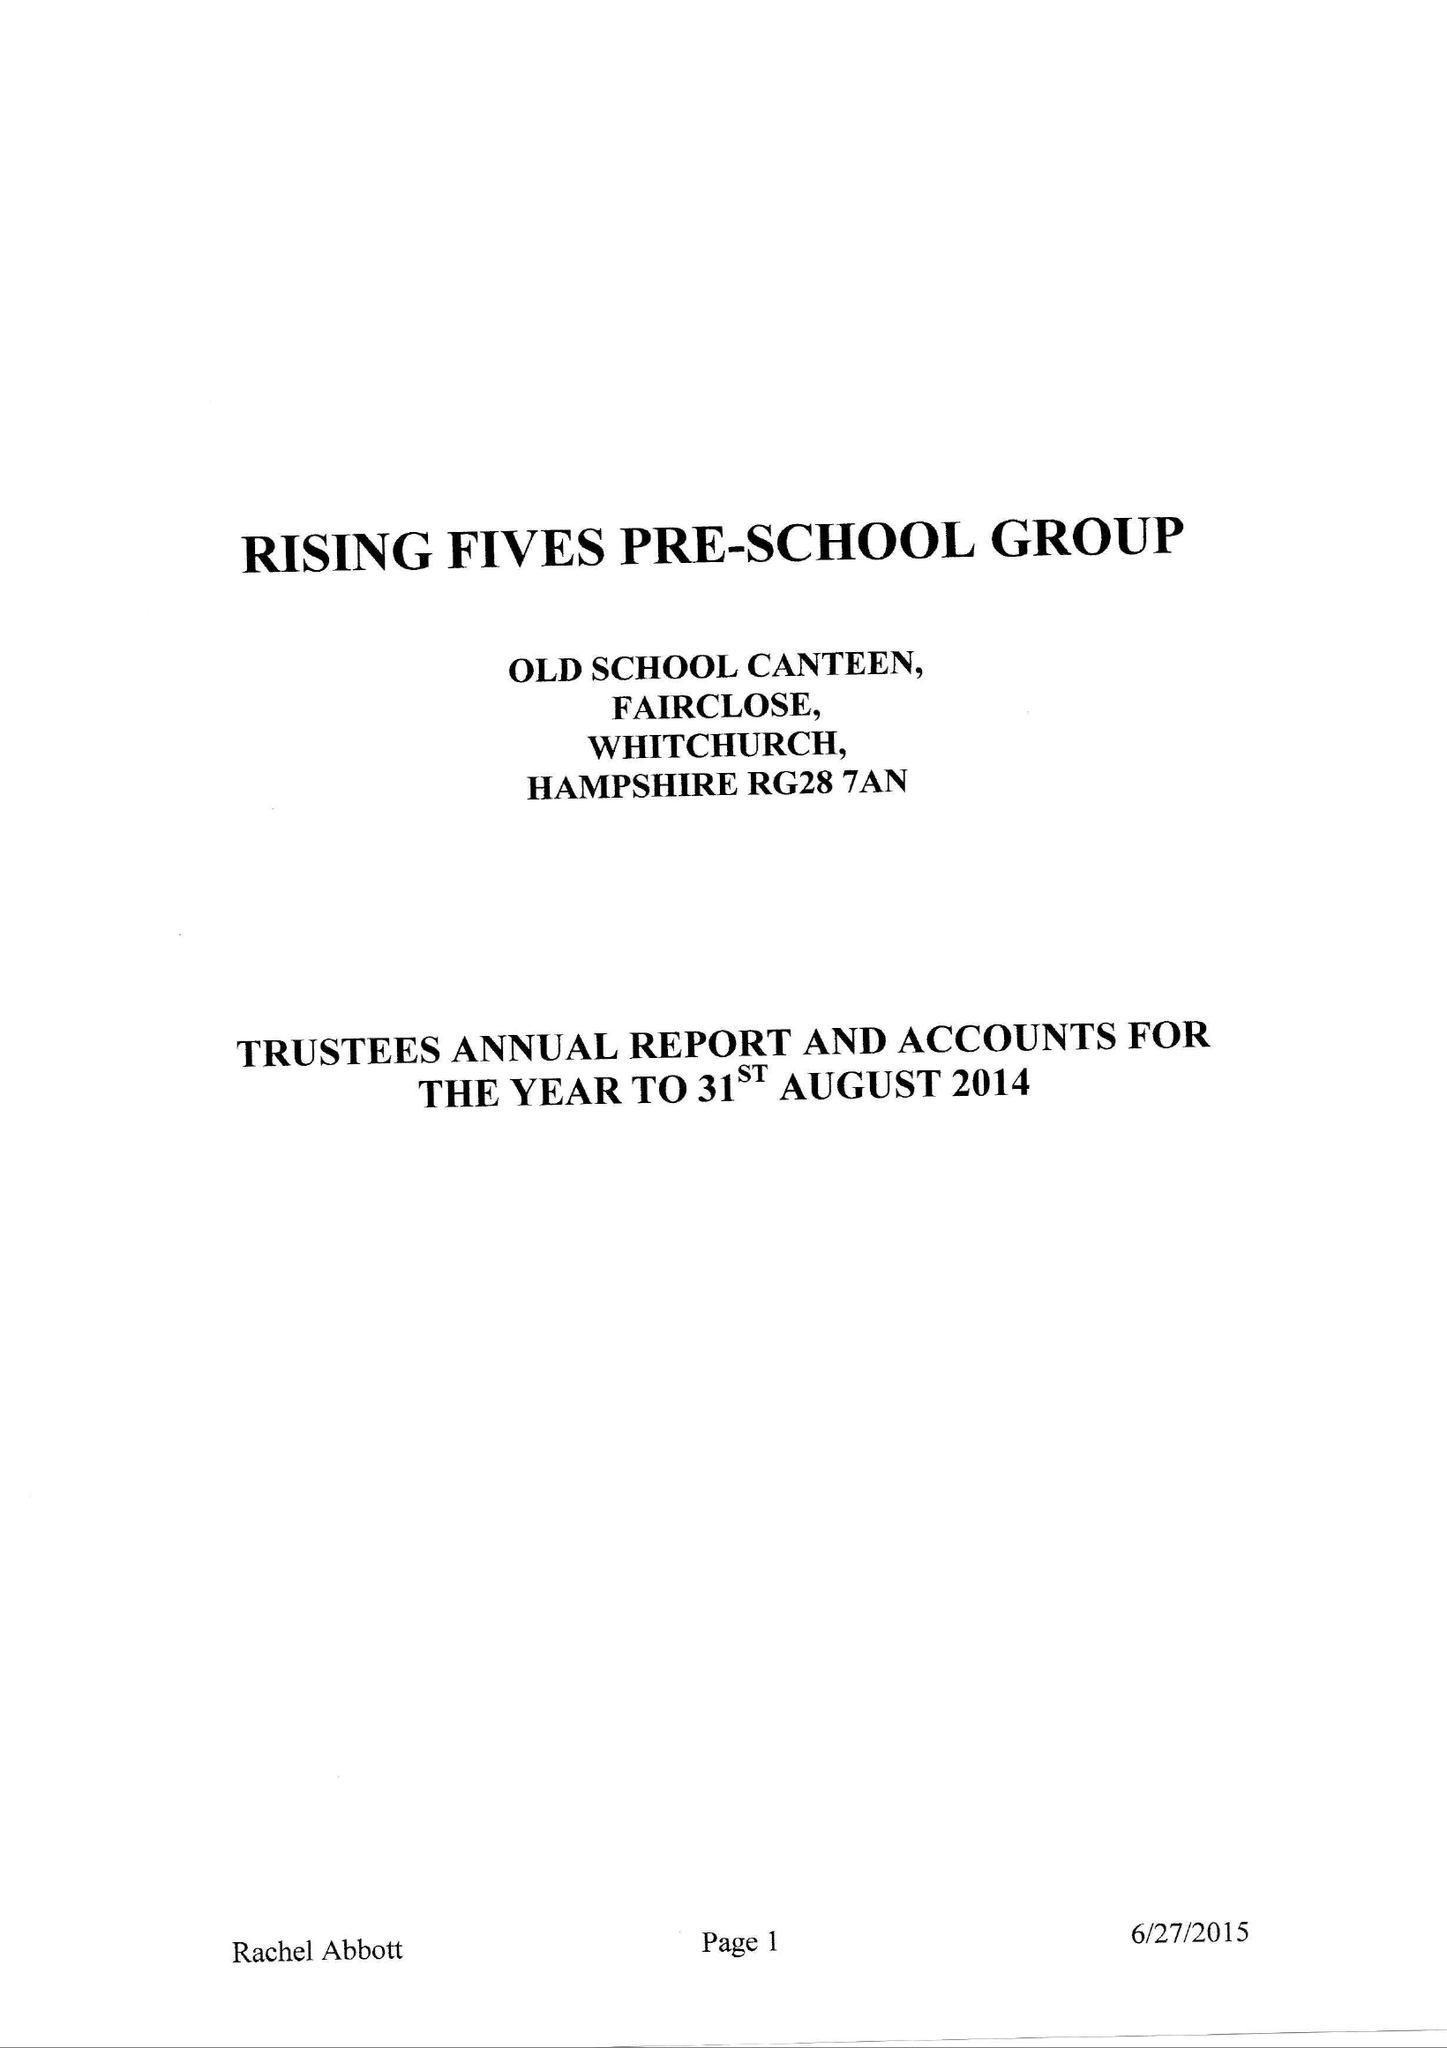What is the value for the income_annually_in_british_pounds?
Answer the question using a single word or phrase. 100294.00 